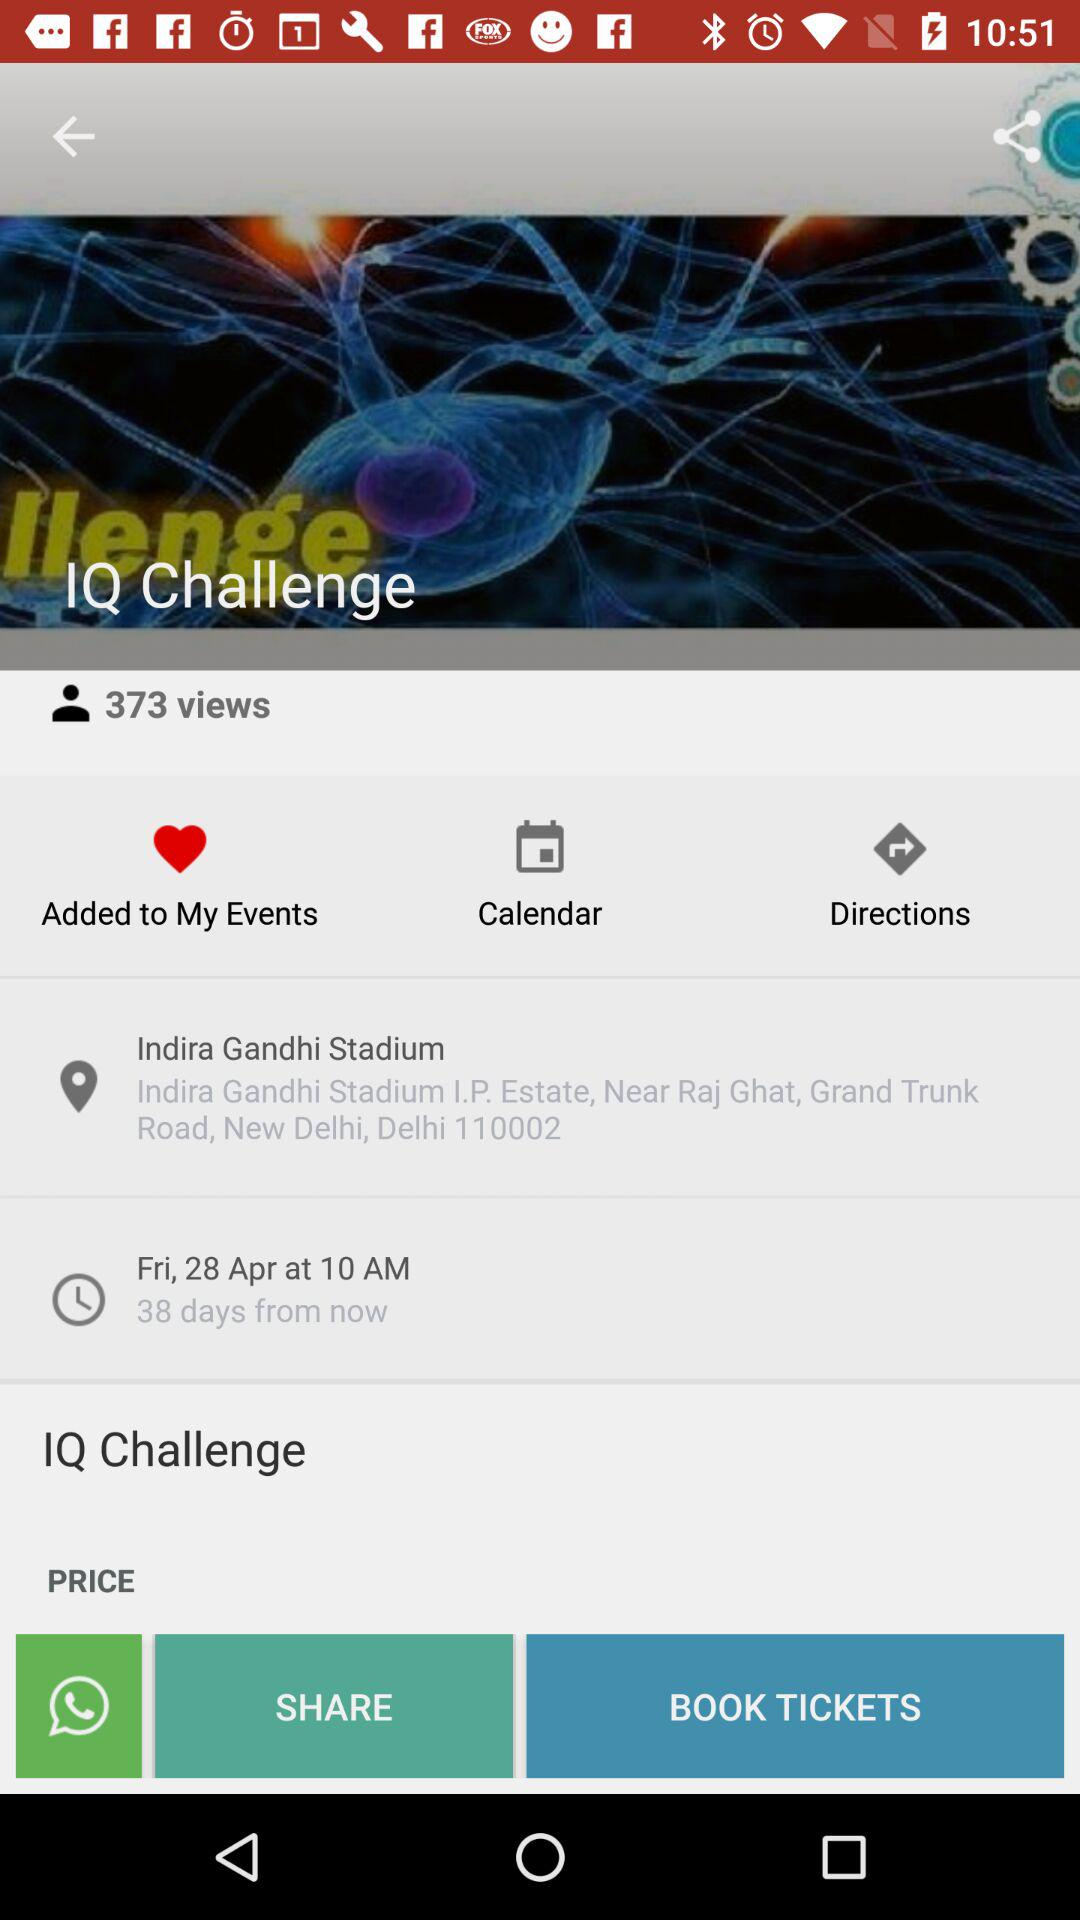What is the date and time? The date is Friday, April 28 and the time is 10 a.m. 